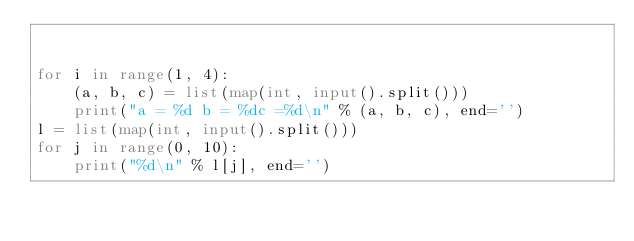<code> <loc_0><loc_0><loc_500><loc_500><_Python_>

for i in range(1, 4):
    (a, b, c) = list(map(int, input().split()))
    print("a = %d b = %dc =%d\n" % (a, b, c), end='')
l = list(map(int, input().split()))
for j in range(0, 10):
    print("%d\n" % l[j], end='')

</code> 